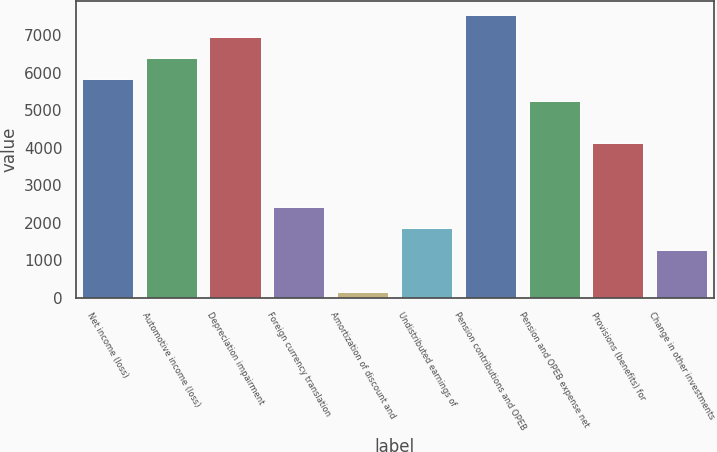Convert chart to OTSL. <chart><loc_0><loc_0><loc_500><loc_500><bar_chart><fcel>Net income (loss)<fcel>Automotive income (loss)<fcel>Depreciation impairment<fcel>Foreign currency translation<fcel>Amortization of discount and<fcel>Undistributed earnings of<fcel>Pension contributions and OPEB<fcel>Pension and OPEB expense net<fcel>Provisions (benefits) for<fcel>Change in other investments<nl><fcel>5832<fcel>6401.2<fcel>6970.4<fcel>2416.8<fcel>140<fcel>1847.6<fcel>7539.6<fcel>5262.8<fcel>4124.4<fcel>1278.4<nl></chart> 